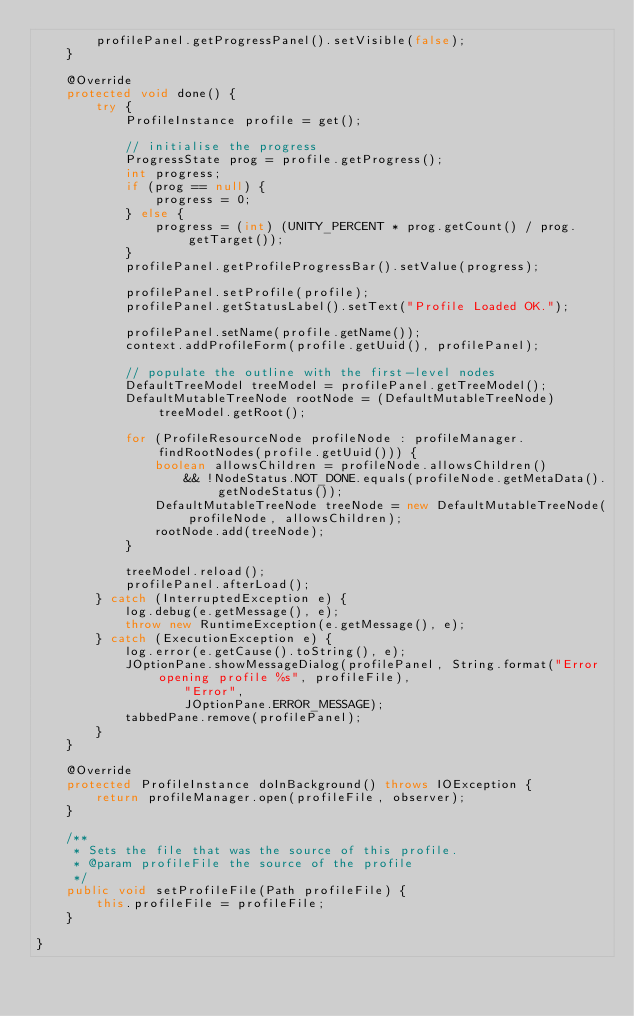<code> <loc_0><loc_0><loc_500><loc_500><_Java_>        profilePanel.getProgressPanel().setVisible(false);
    }

    @Override
    protected void done() {
        try {
            ProfileInstance profile = get();
            
            // initialise the progress
            ProgressState prog = profile.getProgress();
            int progress;
            if (prog == null) {
                progress = 0;
            } else {
                progress = (int) (UNITY_PERCENT * prog.getCount() / prog.getTarget());
            }
            profilePanel.getProfileProgressBar().setValue(progress);

            profilePanel.setProfile(profile);
            profilePanel.getStatusLabel().setText("Profile Loaded OK.");

            profilePanel.setName(profile.getName());
            context.addProfileForm(profile.getUuid(), profilePanel);

            // populate the outline with the first-level nodes
            DefaultTreeModel treeModel = profilePanel.getTreeModel();
            DefaultMutableTreeNode rootNode = (DefaultMutableTreeNode) treeModel.getRoot();
            
            for (ProfileResourceNode profileNode : profileManager.findRootNodes(profile.getUuid())) {
                boolean allowsChildren = profileNode.allowsChildren() 
                    && !NodeStatus.NOT_DONE.equals(profileNode.getMetaData().getNodeStatus());
                DefaultMutableTreeNode treeNode = new DefaultMutableTreeNode(profileNode, allowsChildren);
                rootNode.add(treeNode);
            }

            treeModel.reload();
            profilePanel.afterLoad();
        } catch (InterruptedException e) {
            log.debug(e.getMessage(), e);
            throw new RuntimeException(e.getMessage(), e);
        } catch (ExecutionException e) {
            log.error(e.getCause().toString(), e);
            JOptionPane.showMessageDialog(profilePanel, String.format("Error opening profile %s", profileFile),
                    "Error",
                    JOptionPane.ERROR_MESSAGE);
            tabbedPane.remove(profilePanel);
        }
    }

    @Override
    protected ProfileInstance doInBackground() throws IOException {
        return profileManager.open(profileFile, observer);
    }

    /**
     * Sets the file that was the source of this profile.
     * @param profileFile the source of the profile
     */
    public void setProfileFile(Path profileFile) {
        this.profileFile = profileFile;
    }

}
</code> 